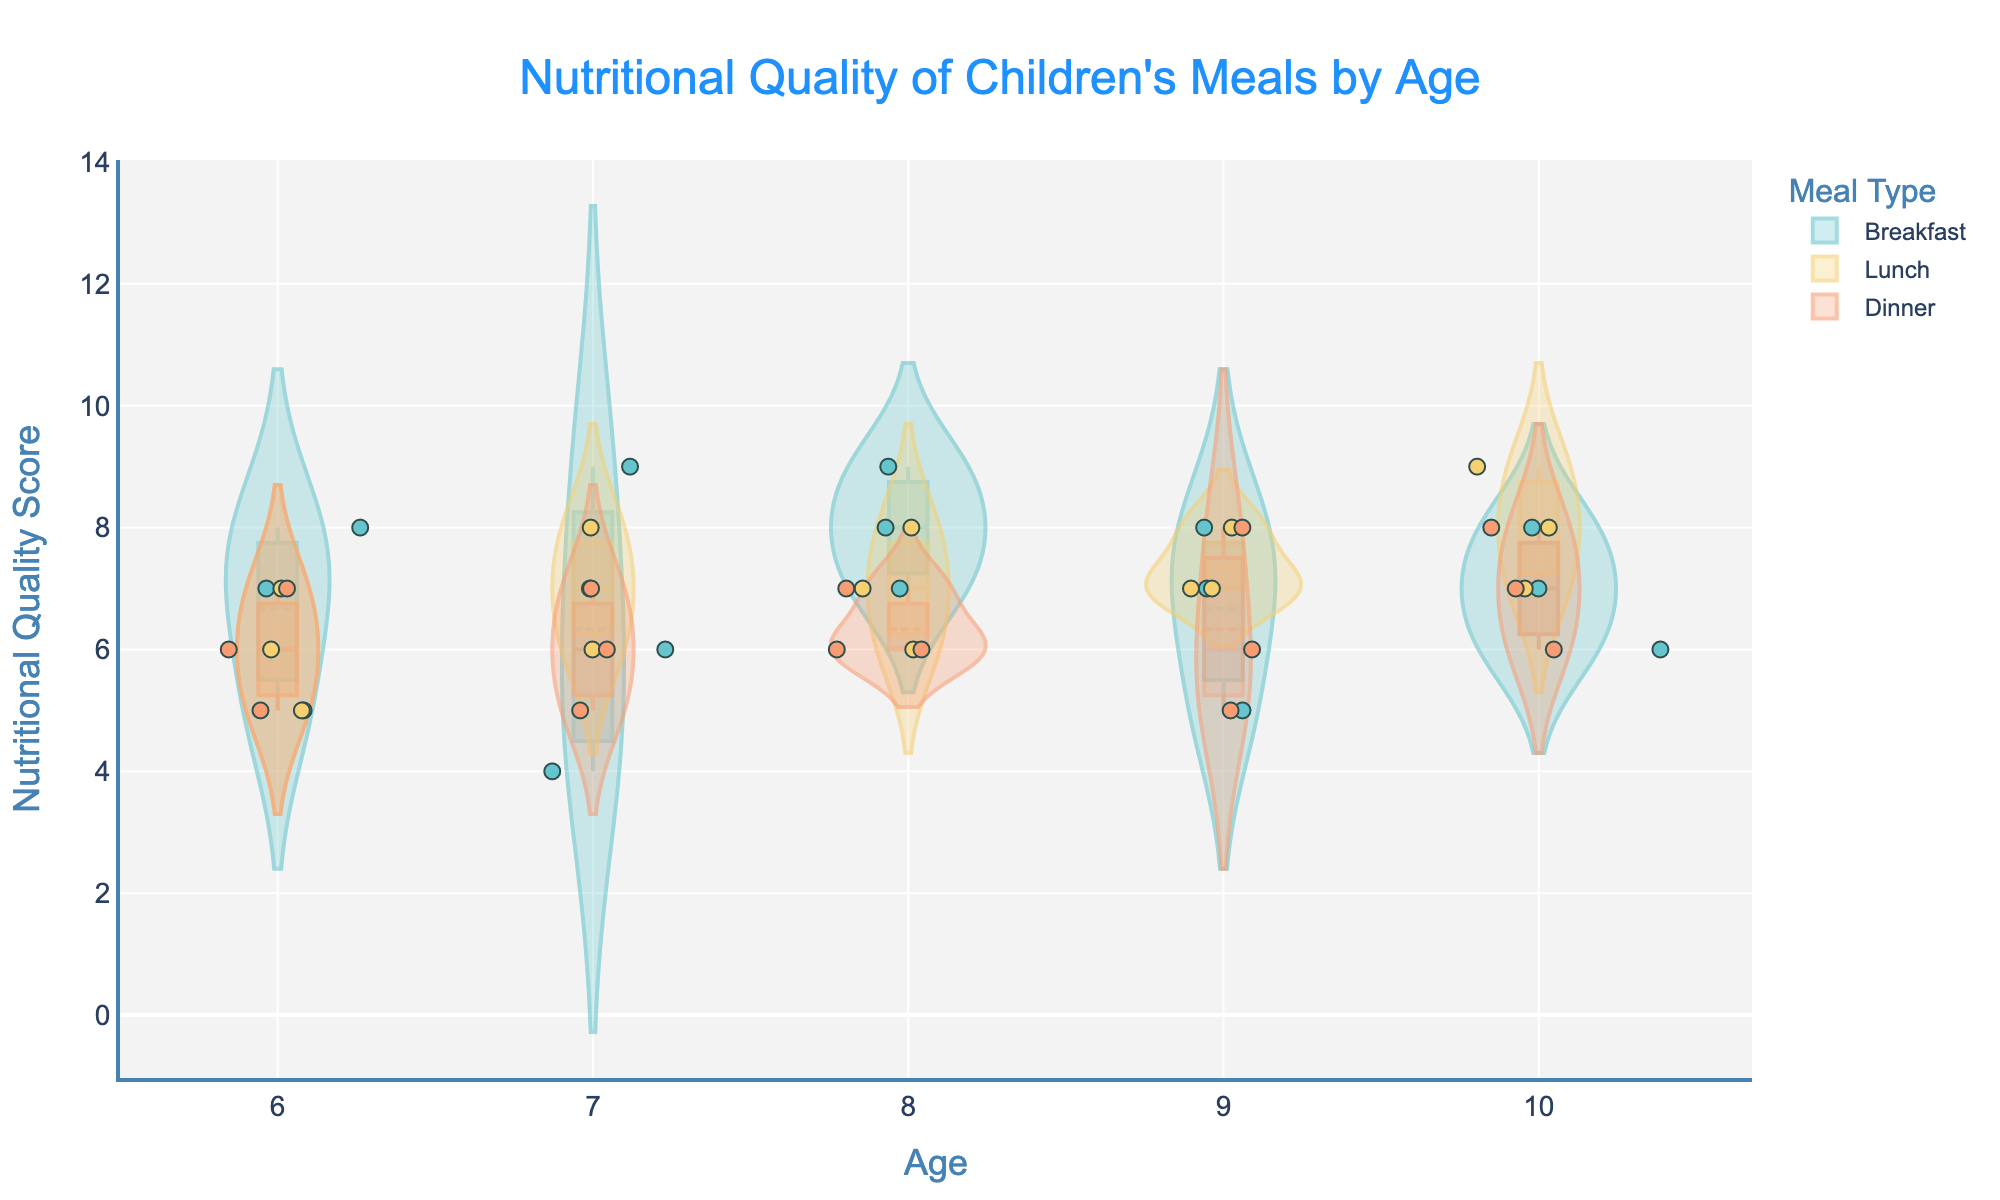what is the title of the plot? The title is the text at the top of the plot that describes what the plot is about. It reads "Nutritional Quality of Children's Meals by Age".
Answer: Nutritional Quality of Children's Meals by Age what is the y-axis measuring? The y-axis title indicates what is being measured on that axis. It reads "Nutritional Quality Score".
Answer: Nutritional Quality Score what are the meal types displayed in the legend? The legend shows the different categories represented in the plot. In this case, the meal types are "Breakfast", "Lunch", and "Dinner".
Answer: Breakfast, Lunch, Dinner at age 8, which meal type has the highest nutritional quality score on average? To find this, observe the mean lines in the violin plots for each meal type at age 8. The breakfast plot has the highest mean value.
Answer: Breakfast how does the spread of nutritional quality scores for dinner at age 9 compare to lunch at age 9? Look at the width and range of the violin plots for dinner and lunch at age 9. Dinner has a wider spread compared to lunch, indicating more variability in scores.
Answer: Dinner has a wider spread are there any age groups where one meal type consistently has the highest nutritional quality? Look for any age where one type of meal stands out across the plots. From age 9, Lunch appears consistently high.
Answer: Lunch which meal type shows the least variability in nutritional quality scores at age 7? Look at the narrowest violin plot at age 7. Breakfast appears to have the least variability as it is the narrowest.
Answer: Breakfast is the average nutritional quality higher for breakfast or dinner at age 10? Compare the mean lines of the violin plots for breakfast and dinner at age 10. Breakfast shows a higher mean line.
Answer: Breakfast how do the nutritional quality scores for lunch at age 6 compare to lunch at age 7? Compare the position and spread of the violin plots for lunch between ages 6 and 7. Age 7 has slightly higher and less varied scores.
Answer: Age 7 has higher scores and less variability what is the range of values for nutritional quality score for breakfast across all ages? Look at the minimum and maximum points in the violin plots for breakfast across all ages. The range is from 4 to 9.
Answer: 4 to 9 